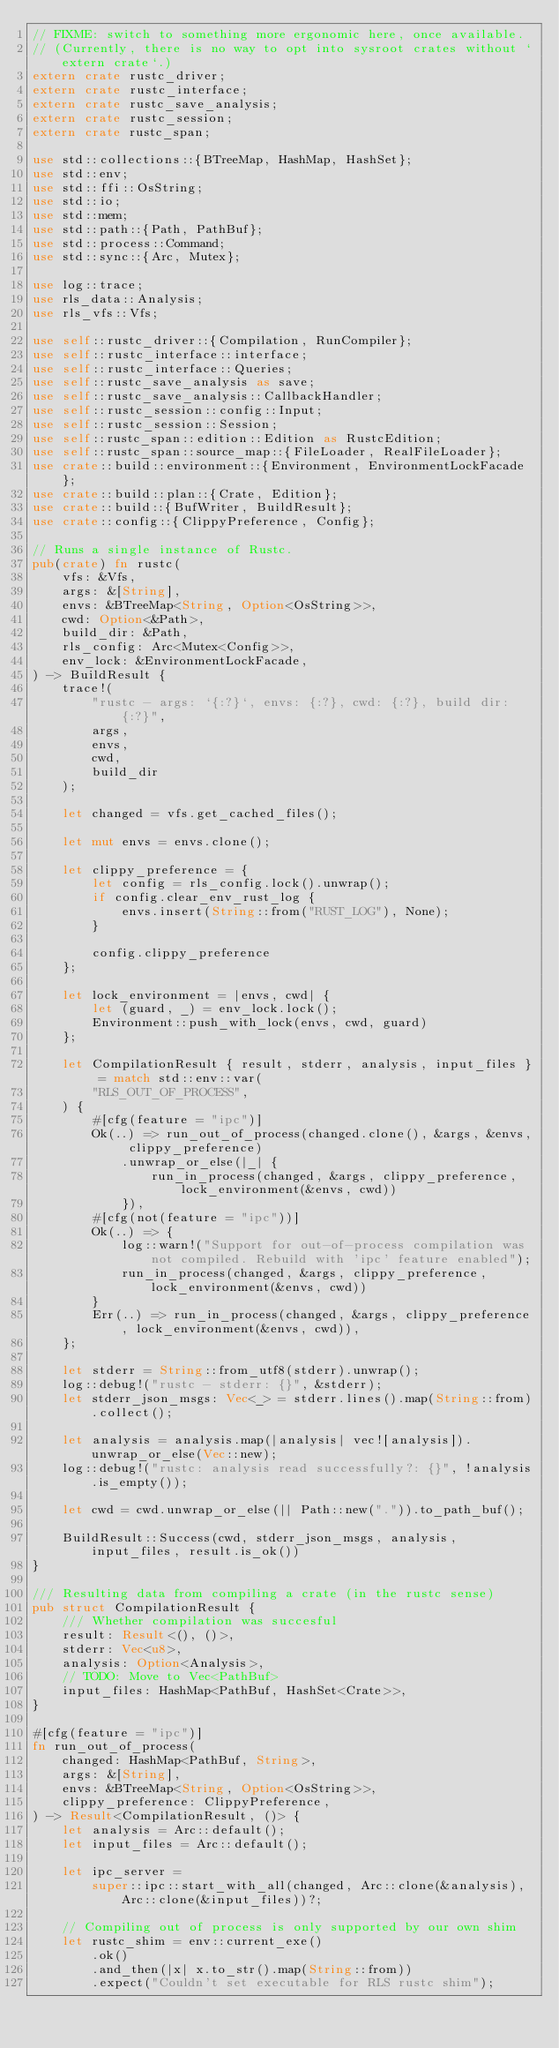Convert code to text. <code><loc_0><loc_0><loc_500><loc_500><_Rust_>// FIXME: switch to something more ergonomic here, once available.
// (Currently, there is no way to opt into sysroot crates without `extern crate`.)
extern crate rustc_driver;
extern crate rustc_interface;
extern crate rustc_save_analysis;
extern crate rustc_session;
extern crate rustc_span;

use std::collections::{BTreeMap, HashMap, HashSet};
use std::env;
use std::ffi::OsString;
use std::io;
use std::mem;
use std::path::{Path, PathBuf};
use std::process::Command;
use std::sync::{Arc, Mutex};

use log::trace;
use rls_data::Analysis;
use rls_vfs::Vfs;

use self::rustc_driver::{Compilation, RunCompiler};
use self::rustc_interface::interface;
use self::rustc_interface::Queries;
use self::rustc_save_analysis as save;
use self::rustc_save_analysis::CallbackHandler;
use self::rustc_session::config::Input;
use self::rustc_session::Session;
use self::rustc_span::edition::Edition as RustcEdition;
use self::rustc_span::source_map::{FileLoader, RealFileLoader};
use crate::build::environment::{Environment, EnvironmentLockFacade};
use crate::build::plan::{Crate, Edition};
use crate::build::{BufWriter, BuildResult};
use crate::config::{ClippyPreference, Config};

// Runs a single instance of Rustc.
pub(crate) fn rustc(
    vfs: &Vfs,
    args: &[String],
    envs: &BTreeMap<String, Option<OsString>>,
    cwd: Option<&Path>,
    build_dir: &Path,
    rls_config: Arc<Mutex<Config>>,
    env_lock: &EnvironmentLockFacade,
) -> BuildResult {
    trace!(
        "rustc - args: `{:?}`, envs: {:?}, cwd: {:?}, build dir: {:?}",
        args,
        envs,
        cwd,
        build_dir
    );

    let changed = vfs.get_cached_files();

    let mut envs = envs.clone();

    let clippy_preference = {
        let config = rls_config.lock().unwrap();
        if config.clear_env_rust_log {
            envs.insert(String::from("RUST_LOG"), None);
        }

        config.clippy_preference
    };

    let lock_environment = |envs, cwd| {
        let (guard, _) = env_lock.lock();
        Environment::push_with_lock(envs, cwd, guard)
    };

    let CompilationResult { result, stderr, analysis, input_files } = match std::env::var(
        "RLS_OUT_OF_PROCESS",
    ) {
        #[cfg(feature = "ipc")]
        Ok(..) => run_out_of_process(changed.clone(), &args, &envs, clippy_preference)
            .unwrap_or_else(|_| {
                run_in_process(changed, &args, clippy_preference, lock_environment(&envs, cwd))
            }),
        #[cfg(not(feature = "ipc"))]
        Ok(..) => {
            log::warn!("Support for out-of-process compilation was not compiled. Rebuild with 'ipc' feature enabled");
            run_in_process(changed, &args, clippy_preference, lock_environment(&envs, cwd))
        }
        Err(..) => run_in_process(changed, &args, clippy_preference, lock_environment(&envs, cwd)),
    };

    let stderr = String::from_utf8(stderr).unwrap();
    log::debug!("rustc - stderr: {}", &stderr);
    let stderr_json_msgs: Vec<_> = stderr.lines().map(String::from).collect();

    let analysis = analysis.map(|analysis| vec![analysis]).unwrap_or_else(Vec::new);
    log::debug!("rustc: analysis read successfully?: {}", !analysis.is_empty());

    let cwd = cwd.unwrap_or_else(|| Path::new(".")).to_path_buf();

    BuildResult::Success(cwd, stderr_json_msgs, analysis, input_files, result.is_ok())
}

/// Resulting data from compiling a crate (in the rustc sense)
pub struct CompilationResult {
    /// Whether compilation was succesful
    result: Result<(), ()>,
    stderr: Vec<u8>,
    analysis: Option<Analysis>,
    // TODO: Move to Vec<PathBuf>
    input_files: HashMap<PathBuf, HashSet<Crate>>,
}

#[cfg(feature = "ipc")]
fn run_out_of_process(
    changed: HashMap<PathBuf, String>,
    args: &[String],
    envs: &BTreeMap<String, Option<OsString>>,
    clippy_preference: ClippyPreference,
) -> Result<CompilationResult, ()> {
    let analysis = Arc::default();
    let input_files = Arc::default();

    let ipc_server =
        super::ipc::start_with_all(changed, Arc::clone(&analysis), Arc::clone(&input_files))?;

    // Compiling out of process is only supported by our own shim
    let rustc_shim = env::current_exe()
        .ok()
        .and_then(|x| x.to_str().map(String::from))
        .expect("Couldn't set executable for RLS rustc shim");
</code> 